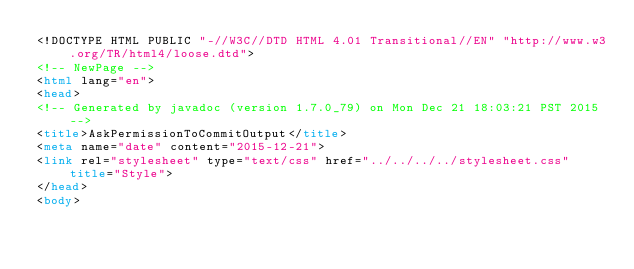Convert code to text. <code><loc_0><loc_0><loc_500><loc_500><_HTML_><!DOCTYPE HTML PUBLIC "-//W3C//DTD HTML 4.01 Transitional//EN" "http://www.w3.org/TR/html4/loose.dtd">
<!-- NewPage -->
<html lang="en">
<head>
<!-- Generated by javadoc (version 1.7.0_79) on Mon Dec 21 18:03:21 PST 2015 -->
<title>AskPermissionToCommitOutput</title>
<meta name="date" content="2015-12-21">
<link rel="stylesheet" type="text/css" href="../../../../stylesheet.css" title="Style">
</head>
<body></code> 